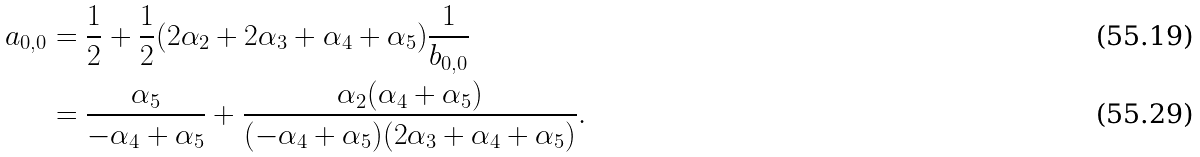Convert formula to latex. <formula><loc_0><loc_0><loc_500><loc_500>a _ { 0 , 0 } & = \frac { 1 } { 2 } + \frac { 1 } { 2 } ( 2 \alpha _ { 2 } + 2 \alpha _ { 3 } + \alpha _ { 4 } + \alpha _ { 5 } ) \frac { 1 } { b _ { 0 , 0 } } \\ & = \frac { \alpha _ { 5 } } { - \alpha _ { 4 } + \alpha _ { 5 } } + \frac { \alpha _ { 2 } ( \alpha _ { 4 } + \alpha _ { 5 } ) } { ( - \alpha _ { 4 } + \alpha _ { 5 } ) ( 2 \alpha _ { 3 } + \alpha _ { 4 } + \alpha _ { 5 } ) } .</formula> 